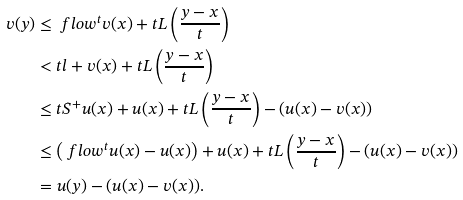<formula> <loc_0><loc_0><loc_500><loc_500>v ( y ) & \leq \ f l o w ^ { t } v ( x ) + t L \left ( \frac { y - x } { t } \right ) \\ & < t l + v ( x ) + t L \left ( \frac { y - x } { t } \right ) \\ & \leq t S ^ { + } u ( x ) + u ( x ) + t L \left ( \frac { y - x } { t } \right ) - ( u ( x ) - v ( x ) ) \\ & \leq \left ( \ f l o w ^ { t } u ( x ) - u ( x ) \right ) + u ( x ) + t L \left ( \frac { y - x } { t } \right ) - ( u ( x ) - v ( x ) ) \\ & = u ( y ) - ( u ( x ) - v ( x ) ) .</formula> 